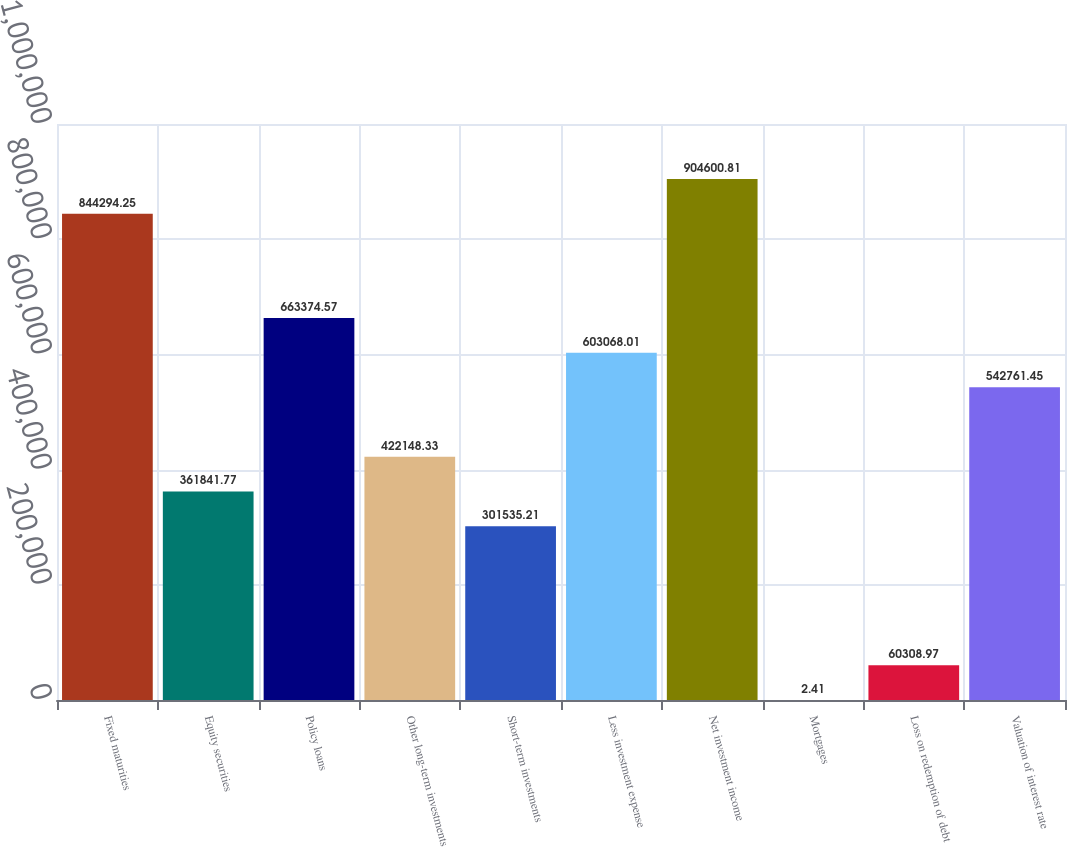<chart> <loc_0><loc_0><loc_500><loc_500><bar_chart><fcel>Fixed maturities<fcel>Equity securities<fcel>Policy loans<fcel>Other long-term investments<fcel>Short-term investments<fcel>Less investment expense<fcel>Net investment income<fcel>Mortgages<fcel>Loss on redemption of debt<fcel>Valuation of interest rate<nl><fcel>844294<fcel>361842<fcel>663375<fcel>422148<fcel>301535<fcel>603068<fcel>904601<fcel>2.41<fcel>60309<fcel>542761<nl></chart> 